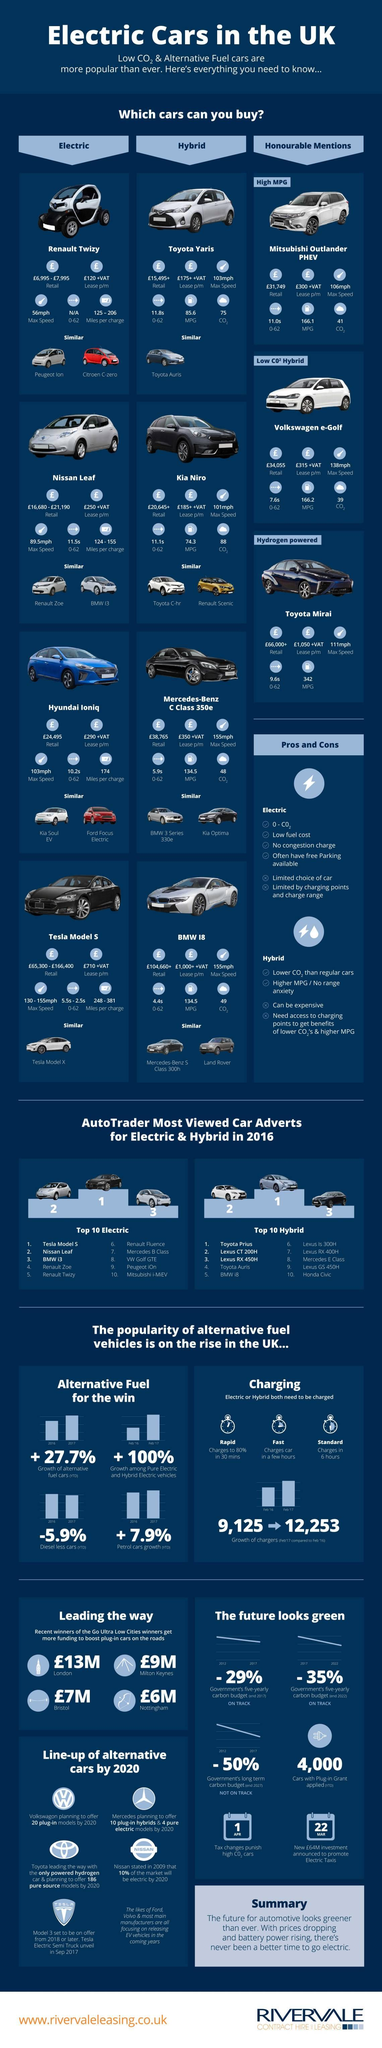Highlight a few significant elements in this photo. The color of the Testa Model S is black. There is one car that is similar to the Testa Model 5. In 2016, the Toyota Prius was the most viewed hybrid car on AutoTrader. The Nissan Leaf has a maximum speed of 89.5 miles per hour. It is estimated that there are approximately 2 cars that are similar in nature to BMW 18. 